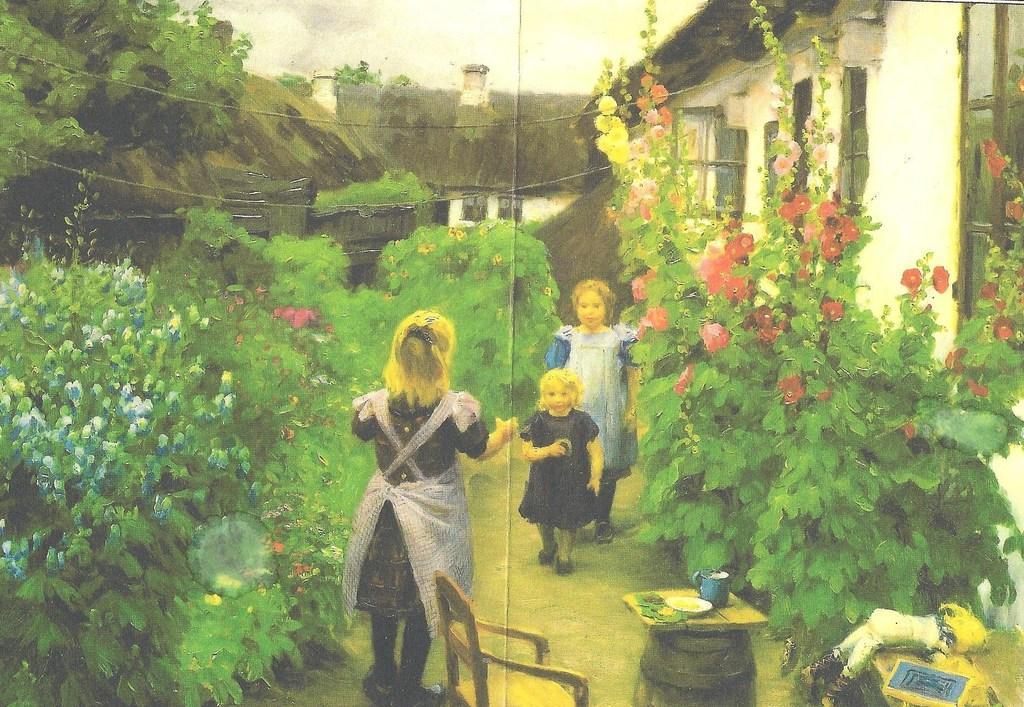Can you describe this image briefly? This image is a painting. In this image there is a lady standing, in front of the lady there are two children walking on the path. On the other sides of the path there are plants and trees, beside the lady there is a chair and table, on the table there are few objects. On the bottom right side there is a toy and a book on the other table. In the background there are houses and a sky. 